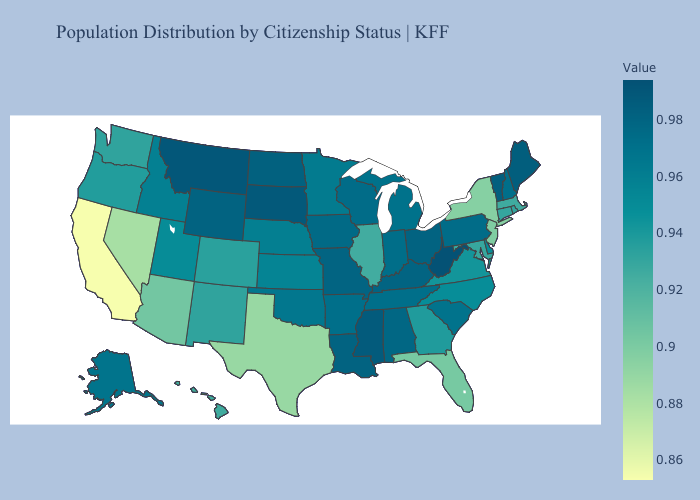Does West Virginia have the highest value in the USA?
Quick response, please. Yes. Among the states that border Florida , does Georgia have the lowest value?
Write a very short answer. Yes. Which states have the lowest value in the USA?
Quick response, please. California. Which states have the lowest value in the MidWest?
Keep it brief. Illinois. Is the legend a continuous bar?
Quick response, please. Yes. Which states hav the highest value in the South?
Keep it brief. West Virginia. Which states hav the highest value in the MidWest?
Write a very short answer. South Dakota. 